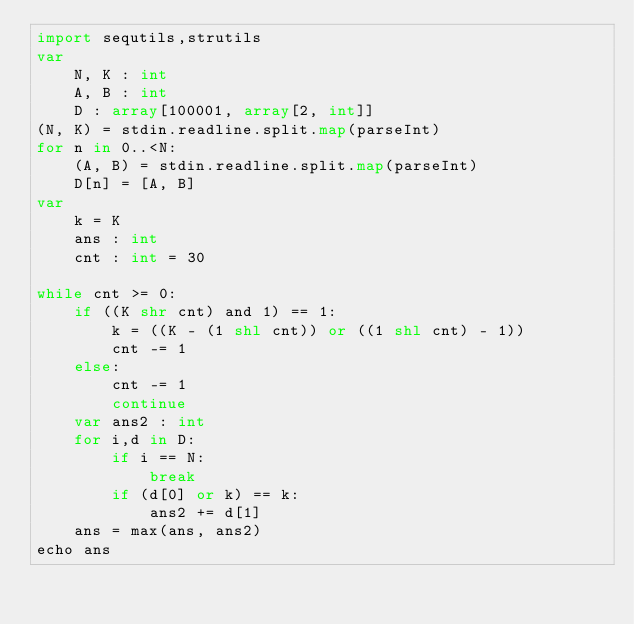<code> <loc_0><loc_0><loc_500><loc_500><_Nim_>import sequtils,strutils
var
    N, K : int
    A, B : int
    D : array[100001, array[2, int]]
(N, K) = stdin.readline.split.map(parseInt)
for n in 0..<N:
    (A, B) = stdin.readline.split.map(parseInt)
    D[n] = [A, B]
var
    k = K
    ans : int
    cnt : int = 30

while cnt >= 0:
    if ((K shr cnt) and 1) == 1:
        k = ((K - (1 shl cnt)) or ((1 shl cnt) - 1))
        cnt -= 1
    else:
        cnt -= 1
        continue
    var ans2 : int
    for i,d in D:
        if i == N:
            break
        if (d[0] or k) == k:
            ans2 += d[1]
    ans = max(ans, ans2)
echo ans</code> 